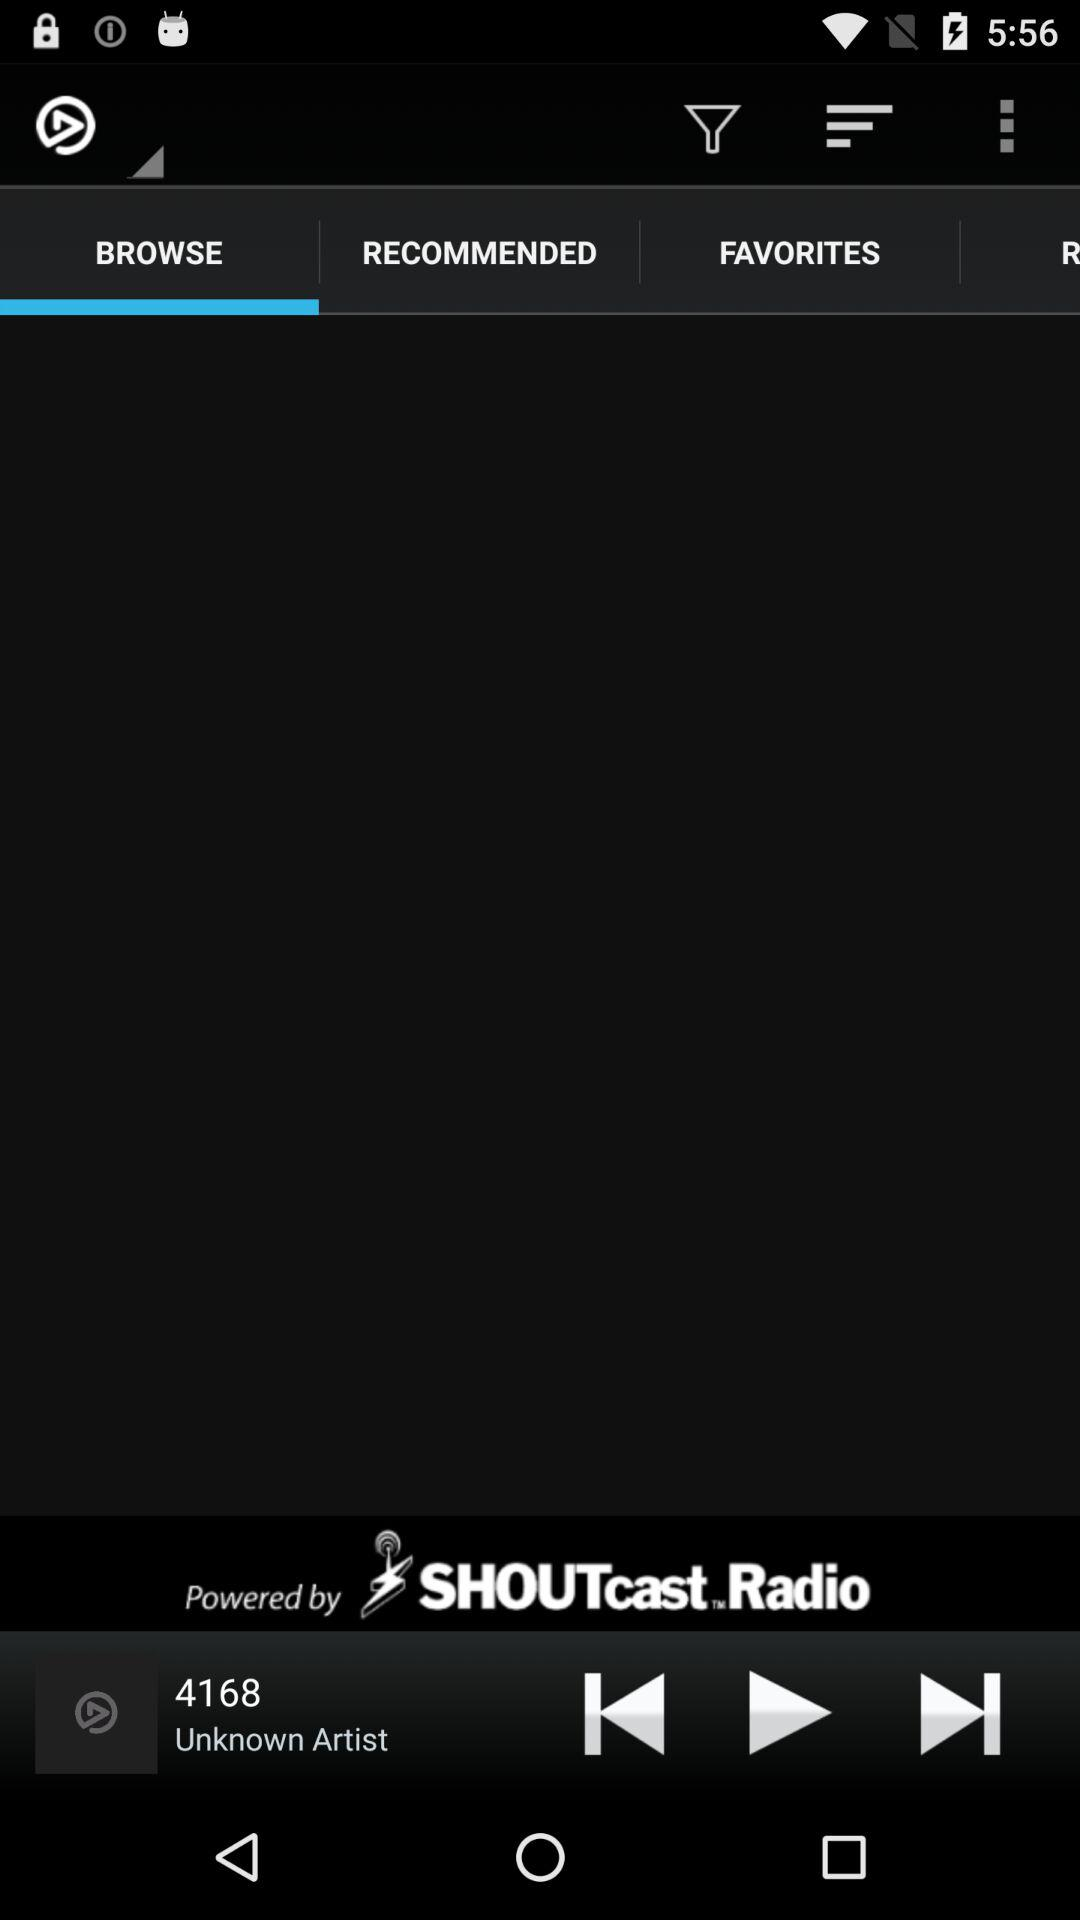Which audio was last played? The last played audio was "4168". 